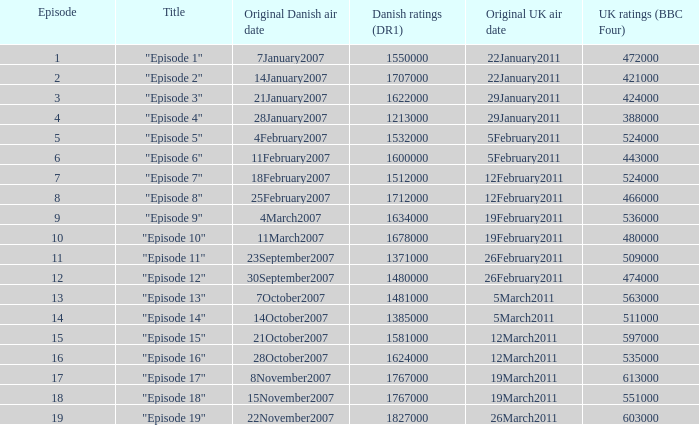What were the UK ratings (BBC Four) for "Episode 17"?  613000.0. 